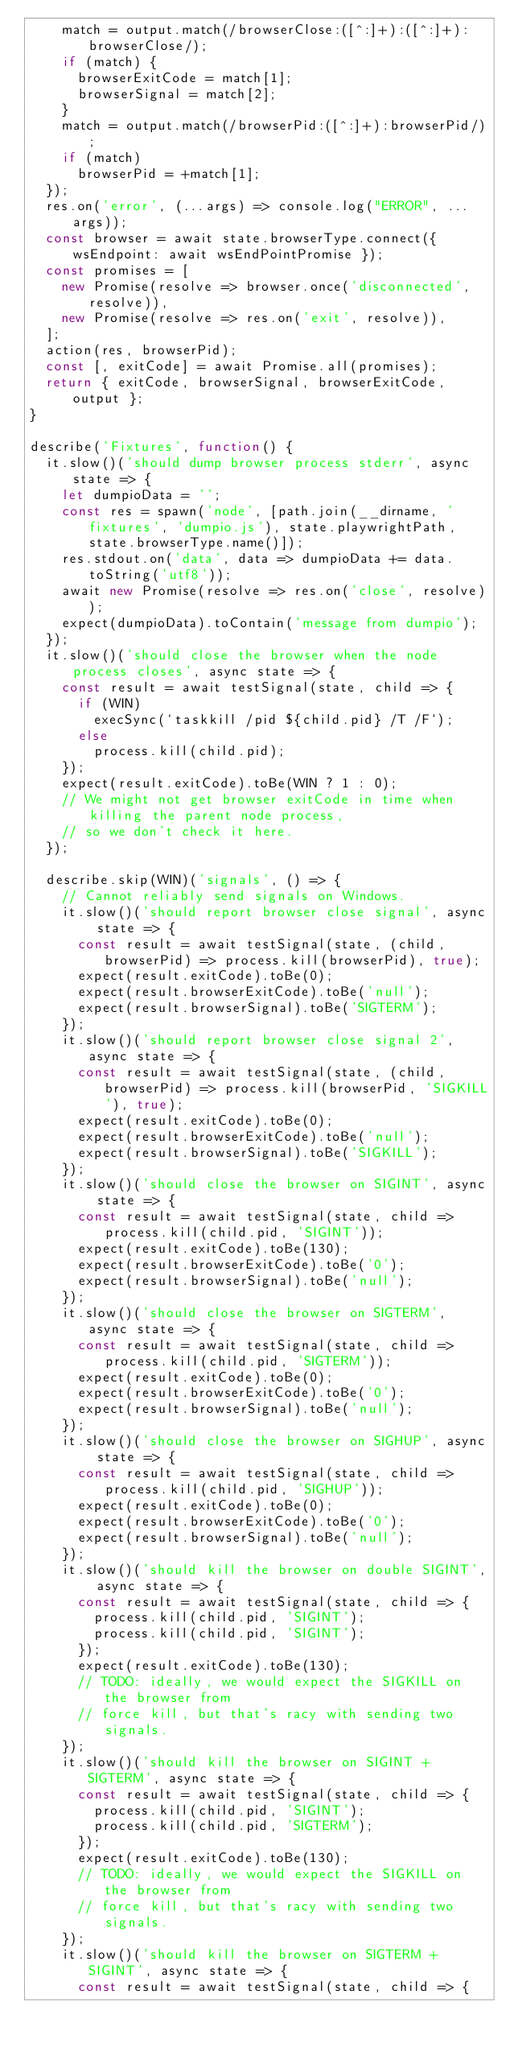<code> <loc_0><loc_0><loc_500><loc_500><_JavaScript_>    match = output.match(/browserClose:([^:]+):([^:]+):browserClose/);
    if (match) {
      browserExitCode = match[1];
      browserSignal = match[2];
    }
    match = output.match(/browserPid:([^:]+):browserPid/);
    if (match)
      browserPid = +match[1];
  });
  res.on('error', (...args) => console.log("ERROR", ...args));
  const browser = await state.browserType.connect({ wsEndpoint: await wsEndPointPromise });
  const promises = [
    new Promise(resolve => browser.once('disconnected', resolve)),
    new Promise(resolve => res.on('exit', resolve)),
  ];
  action(res, browserPid);
  const [, exitCode] = await Promise.all(promises);
  return { exitCode, browserSignal, browserExitCode, output };
}

describe('Fixtures', function() {
  it.slow()('should dump browser process stderr', async state => {
    let dumpioData = '';
    const res = spawn('node', [path.join(__dirname, 'fixtures', 'dumpio.js'), state.playwrightPath, state.browserType.name()]);
    res.stdout.on('data', data => dumpioData += data.toString('utf8'));
    await new Promise(resolve => res.on('close', resolve));
    expect(dumpioData).toContain('message from dumpio');
  });
  it.slow()('should close the browser when the node process closes', async state => {
    const result = await testSignal(state, child => {
      if (WIN)
        execSync(`taskkill /pid ${child.pid} /T /F`);
      else
        process.kill(child.pid);
    });
    expect(result.exitCode).toBe(WIN ? 1 : 0);
    // We might not get browser exitCode in time when killing the parent node process,
    // so we don't check it here.
  });

  describe.skip(WIN)('signals', () => {
    // Cannot reliably send signals on Windows.
    it.slow()('should report browser close signal', async state => {
      const result = await testSignal(state, (child, browserPid) => process.kill(browserPid), true);
      expect(result.exitCode).toBe(0);
      expect(result.browserExitCode).toBe('null');
      expect(result.browserSignal).toBe('SIGTERM');
    });
    it.slow()('should report browser close signal 2', async state => {
      const result = await testSignal(state, (child, browserPid) => process.kill(browserPid, 'SIGKILL'), true);
      expect(result.exitCode).toBe(0);
      expect(result.browserExitCode).toBe('null');
      expect(result.browserSignal).toBe('SIGKILL');
    });
    it.slow()('should close the browser on SIGINT', async state => {
      const result = await testSignal(state, child => process.kill(child.pid, 'SIGINT'));
      expect(result.exitCode).toBe(130);
      expect(result.browserExitCode).toBe('0');
      expect(result.browserSignal).toBe('null');
    });
    it.slow()('should close the browser on SIGTERM', async state => {
      const result = await testSignal(state, child => process.kill(child.pid, 'SIGTERM'));
      expect(result.exitCode).toBe(0);
      expect(result.browserExitCode).toBe('0');
      expect(result.browserSignal).toBe('null');
    });
    it.slow()('should close the browser on SIGHUP', async state => {
      const result = await testSignal(state, child => process.kill(child.pid, 'SIGHUP'));
      expect(result.exitCode).toBe(0);
      expect(result.browserExitCode).toBe('0');
      expect(result.browserSignal).toBe('null');
    });
    it.slow()('should kill the browser on double SIGINT', async state => {
      const result = await testSignal(state, child => {
        process.kill(child.pid, 'SIGINT');
        process.kill(child.pid, 'SIGINT');
      });
      expect(result.exitCode).toBe(130);
      // TODO: ideally, we would expect the SIGKILL on the browser from
      // force kill, but that's racy with sending two signals.
    });
    it.slow()('should kill the browser on SIGINT + SIGTERM', async state => {
      const result = await testSignal(state, child => {
        process.kill(child.pid, 'SIGINT');
        process.kill(child.pid, 'SIGTERM');
      });
      expect(result.exitCode).toBe(130);
      // TODO: ideally, we would expect the SIGKILL on the browser from
      // force kill, but that's racy with sending two signals.
    });
    it.slow()('should kill the browser on SIGTERM + SIGINT', async state => {
      const result = await testSignal(state, child => {</code> 